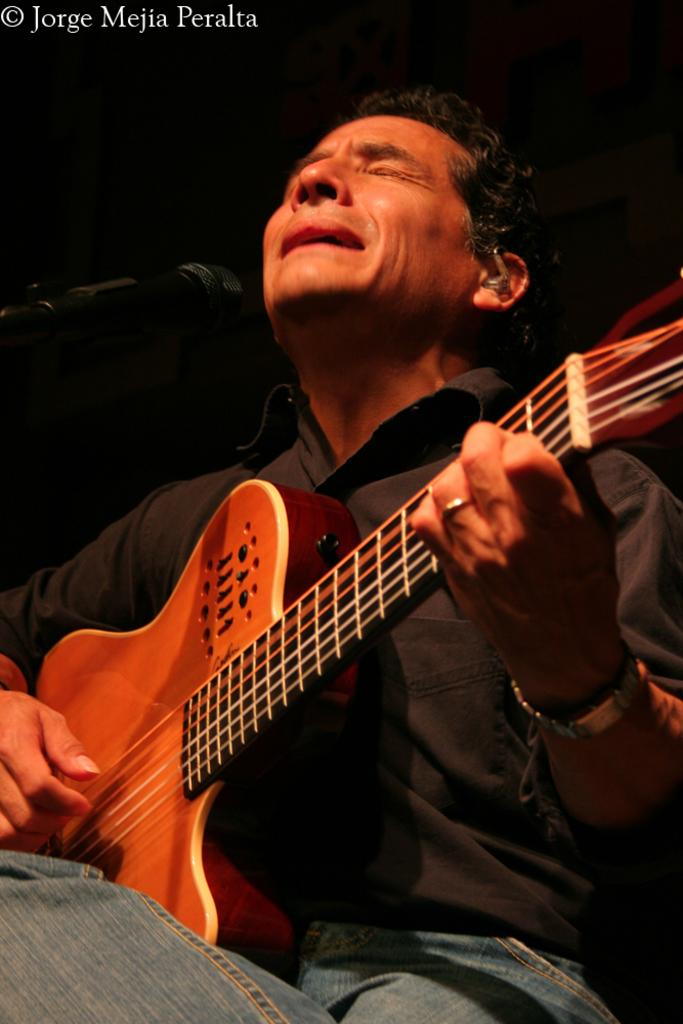What is the man in the image doing? The man is playing a guitar. What is the man positioned in front of in the image? The man is in front of a microphone. What color is the shirt the man is wearing? The man is wearing a black shirt. What type of pants is the man wearing? The man is wearing jeans. What time is the train scheduled to arrive in the image? There is no train present in the image, so it is not possible to determine the arrival time of a train. 